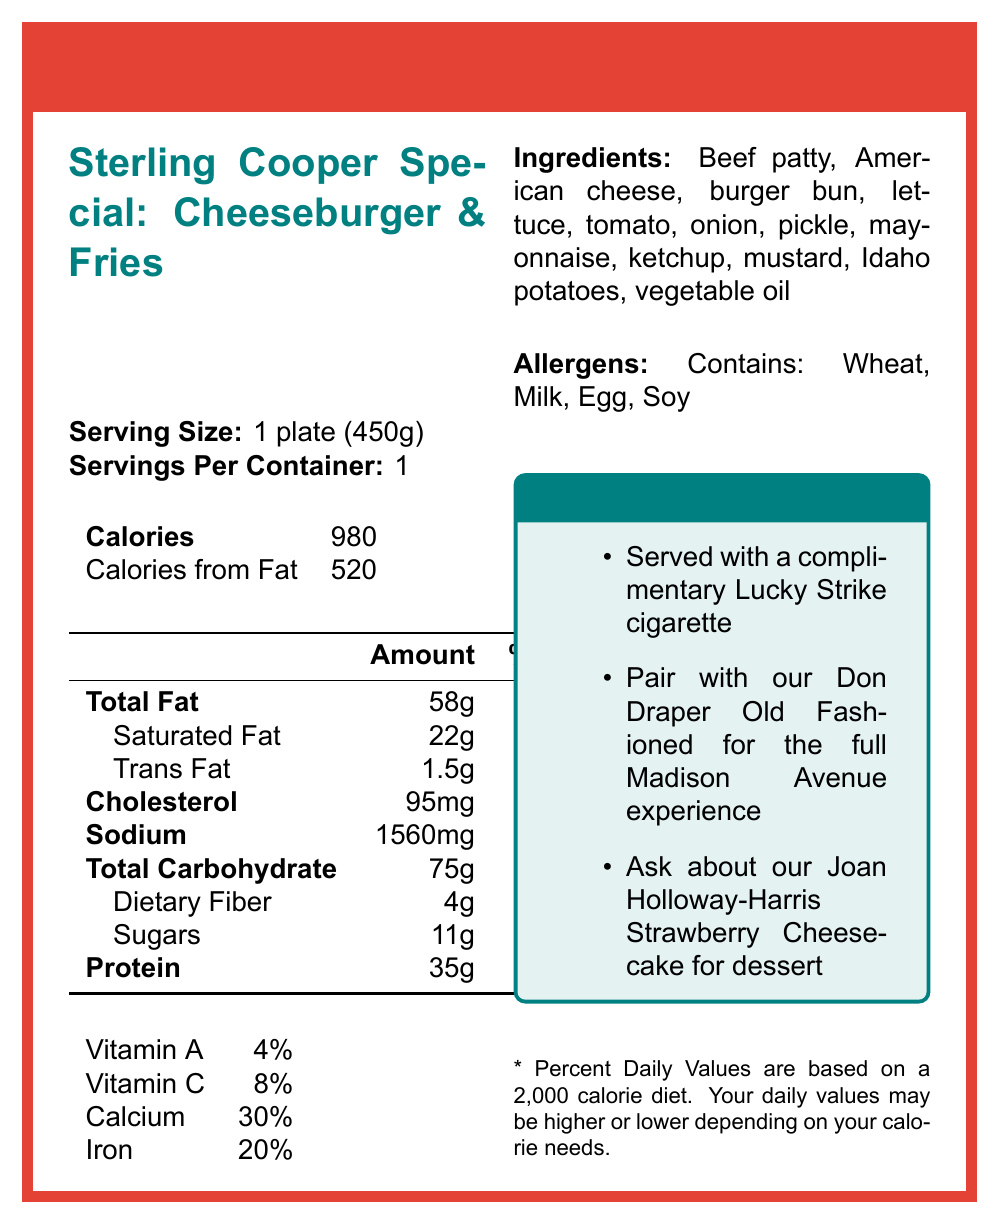what is the serving size? The document states that the serving size is 1 plate (450g).
Answer: 1 plate (450g) how many calories are in the Sterling Cooper Special: Cheeseburger & Fries? The document lists the caloric content as 980 calories.
Answer: 980 how much sodium does the dish contain? According to the document, the sodium content is 1560mg.
Answer: 1560mg what percentage of the daily value does the saturated fat content represent? The document indicates that the saturated fat content is 22g, which is 110% of the daily value.
Answer: 110% what are the allergens listed in the document? The allergens section of the document states that the dish contains Wheat, Milk, Egg, and Soy.
Answer: Wheat, Milk, Egg, Soy how much of calories are from fat? The document specifies that out of 980 total calories, 520 are from fat.
Answer: 520 what vitamins are mentioned and what are their daily values? The document lists these vitamins along with their daily values in a tabular form.
Answer: Vitamin A: 4%, Vitamin C: 8%, Calcium: 30%, Iron: 20% how many grams of protein does the dish contain? According to the document, the dish contains 35g of protein.
Answer: 35g what is the main color scheme used in the design elements? The design elements section mentions that the color scheme consists of Red, White, and Teal.
Answer: Red, White, and Teal does the nutritional information document pair the dish with another item? If so, what? The special notes section mentions pairing the Cheeseburger & Fries with a Don Draper Old Fashioned for the full Madison Avenue experience.
Answer: Yes, Don Draper Old Fashioned what is a complimentary item mentioned with the dish? The special notes section indicates that the dish is served with a complimentary Lucky Strike cigarette.
Answer: Lucky Strike cigarette which of the following is not explicitly mentioned as an ingredient? A. Beef patty B. American cheese C. Swiss cheese D. Idaho potatoes The ingredients list includes Beef patty, American cheese, burger bun, lettuce, tomato, onion, pickle, mayonnaise, ketchup, mustard, Idaho potatoes, vegetable oil but not Swiss cheese.
Answer: C. Swiss cheese what additional dessert option is promoted in the special notes? A. Vanilla shake B. Joan Holloway-Harris Strawberry Cheesecake C. Brownie Sundae D. Apple Pie The special notes specifically promote the Joan Holloway-Harris Strawberry Cheesecake for dessert.
Answer: B. Joan Holloway-Harris Strawberry Cheesecake is the information about trans fat complete? The document lists the amount of trans fat as 1.5g but does not provide a daily value percentage.
Answer: No what is the daily value for dietary fiber according to the document? The document states that the dietary fiber content is 4g, which corresponds to 16% of the daily value.
Answer: 16% write a summary of the document. The document is a nutrition facts label designed to look like a 1960s diner menu, providing detailed nutritional content for a cheeseburger and fries dish. It includes serving size, calorie breakdown, nutrient amounts, daily values, ingredients, and allergens. Special notes and retro design elements enhance the nostalgic feel.
Answer: The document is a nutrition facts label for "Peggy's Diner" featuring the "Sterling Cooper Special: Cheeseburger & Fries." It details the serving size (1 plate, 450g), calories (980), and breakdown of nutrients including fat, cholesterol, sodium, and carbohydrates. The label also lists vitamins and minerals, ingredients, allergens, and special notes. The design elements include retro-themed fonts and colors, with illustrations. what is the font style used in the design elements? The document's design elements section states that the font style is Retro Sans-Serif.
Answer: Retro Sans-Serif what would be the best food recommendation for someone avoiding soy? The document does not provide alternative food recommendations for someone avoiding soy.
Answer: Not enough information what is the suggested drink to pair with the dish for the "full Madison Avenue experience"? The special notes section suggests pairing the dish with a Don Draper Old Fashioned for the full Madison Avenue experience.
Answer: Don Draper Old Fashioned 